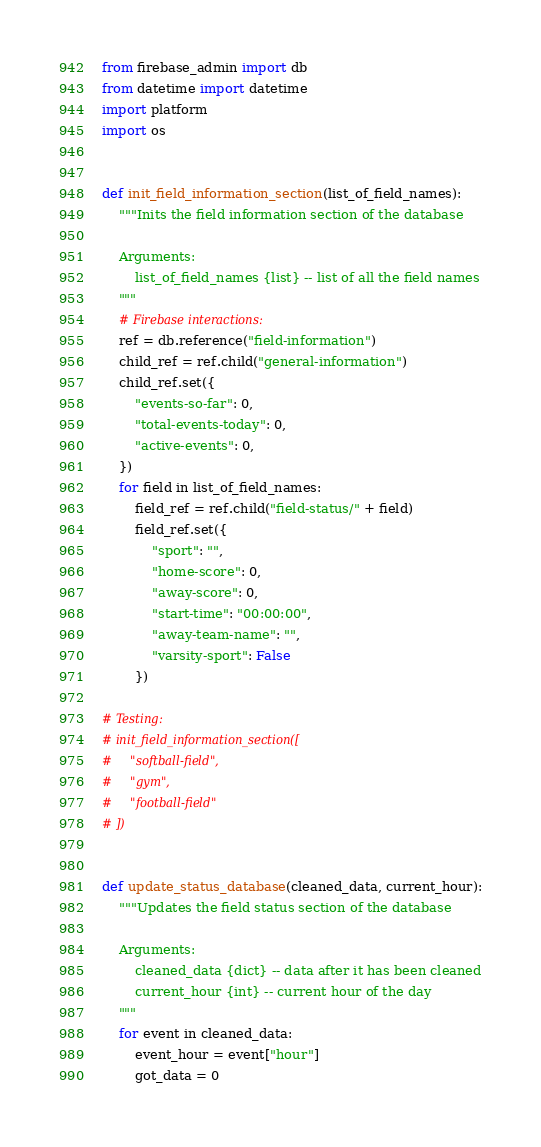<code> <loc_0><loc_0><loc_500><loc_500><_Python_>from firebase_admin import db
from datetime import datetime
import platform
import os


def init_field_information_section(list_of_field_names):
    """Inits the field information section of the database

    Arguments:
        list_of_field_names {list} -- list of all the field names
    """
    # Firebase interactions:
    ref = db.reference("field-information")
    child_ref = ref.child("general-information")
    child_ref.set({
        "events-so-far": 0,
        "total-events-today": 0,
        "active-events": 0,
    })
    for field in list_of_field_names:
        field_ref = ref.child("field-status/" + field)
        field_ref.set({
            "sport": "",
            "home-score": 0,
            "away-score": 0,
            "start-time": "00:00:00",
            "away-team-name": "",
            "varsity-sport": False
        })

# Testing:
# init_field_information_section([
#     "softball-field",
#     "gym",
#     "football-field"
# ])


def update_status_database(cleaned_data, current_hour):
    """Updates the field status section of the database

    Arguments:
        cleaned_data {dict} -- data after it has been cleaned
        current_hour {int} -- current hour of the day
    """
    for event in cleaned_data:
        event_hour = event["hour"]
        got_data = 0</code> 